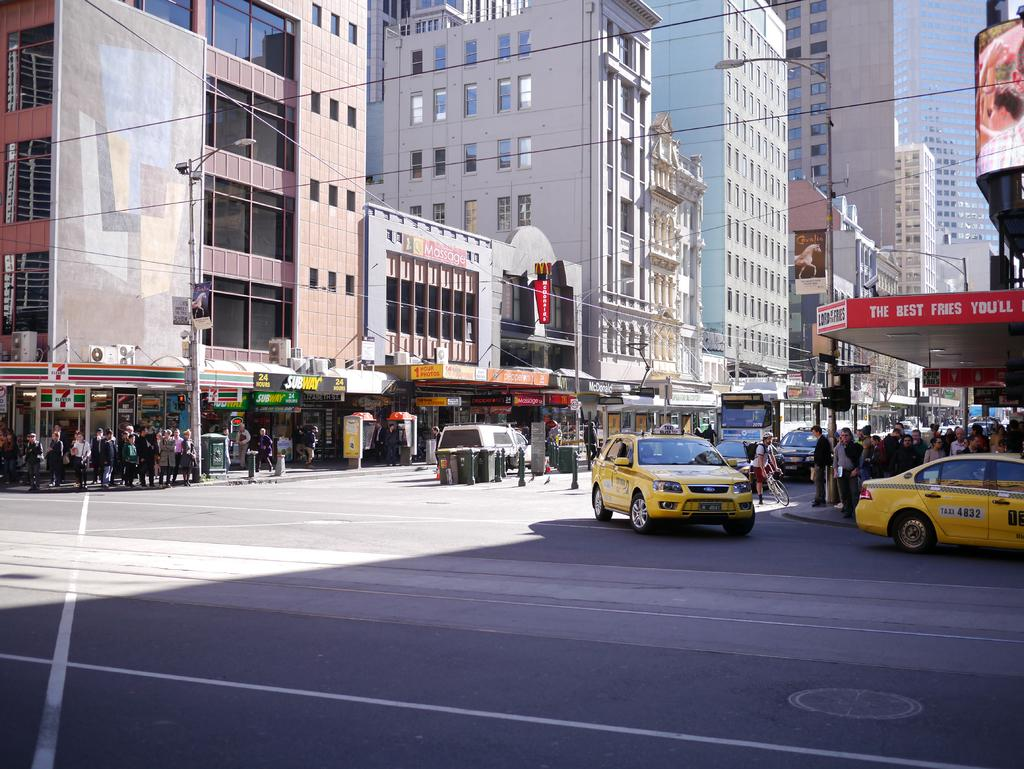<image>
Write a terse but informative summary of the picture. an ad for the best fries with cars around 